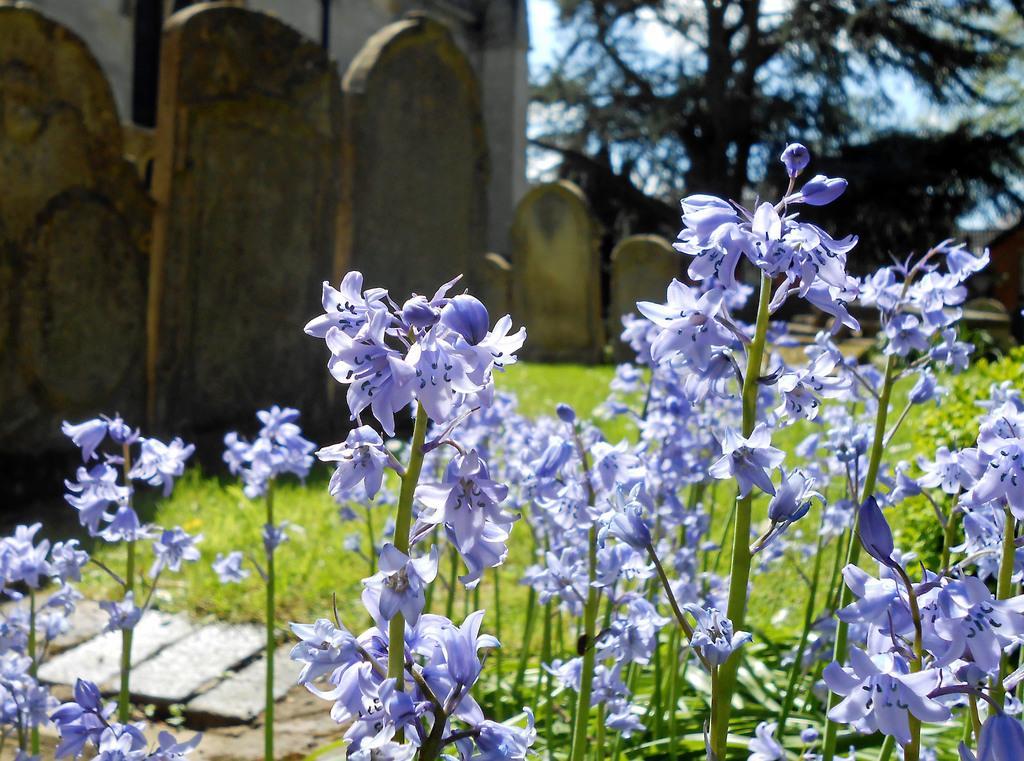In one or two sentences, can you explain what this image depicts? In the front of the image I can see flowers and stems. In the background of the image there is a grass, memorial stones and trees. Through trees sky is visible. 